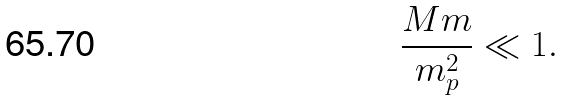Convert formula to latex. <formula><loc_0><loc_0><loc_500><loc_500>\frac { M m } { m _ { p } ^ { 2 } } \ll 1 .</formula> 